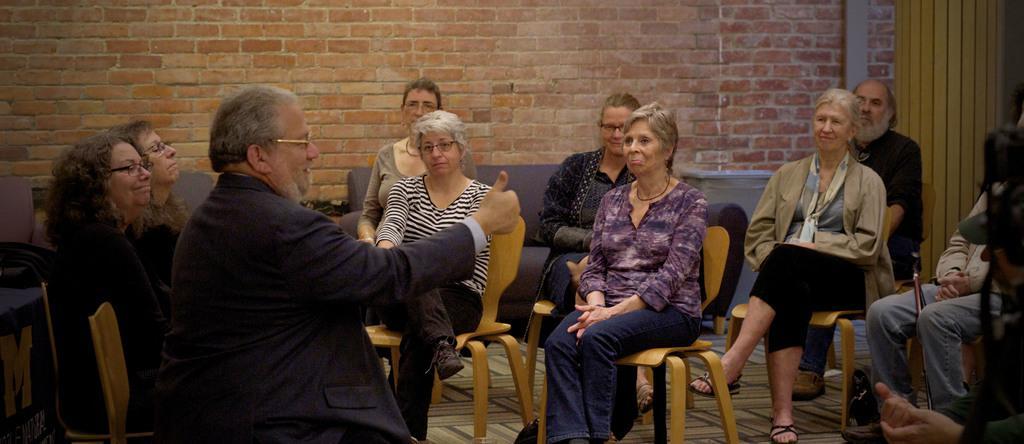Please provide a concise description of this image. There are group of people sitting on the chairs listening to the one person who is speaking in front of them. The person is wearing a spectacles and suit. In the background there is sofa and wall which is constructed with blocks. 